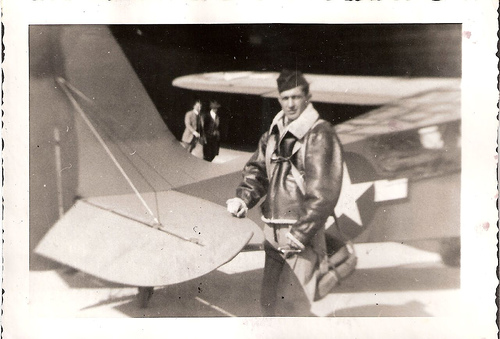<image>
Is the plane on the jacker? No. The plane is not positioned on the jacker. They may be near each other, but the plane is not supported by or resting on top of the jacker. 